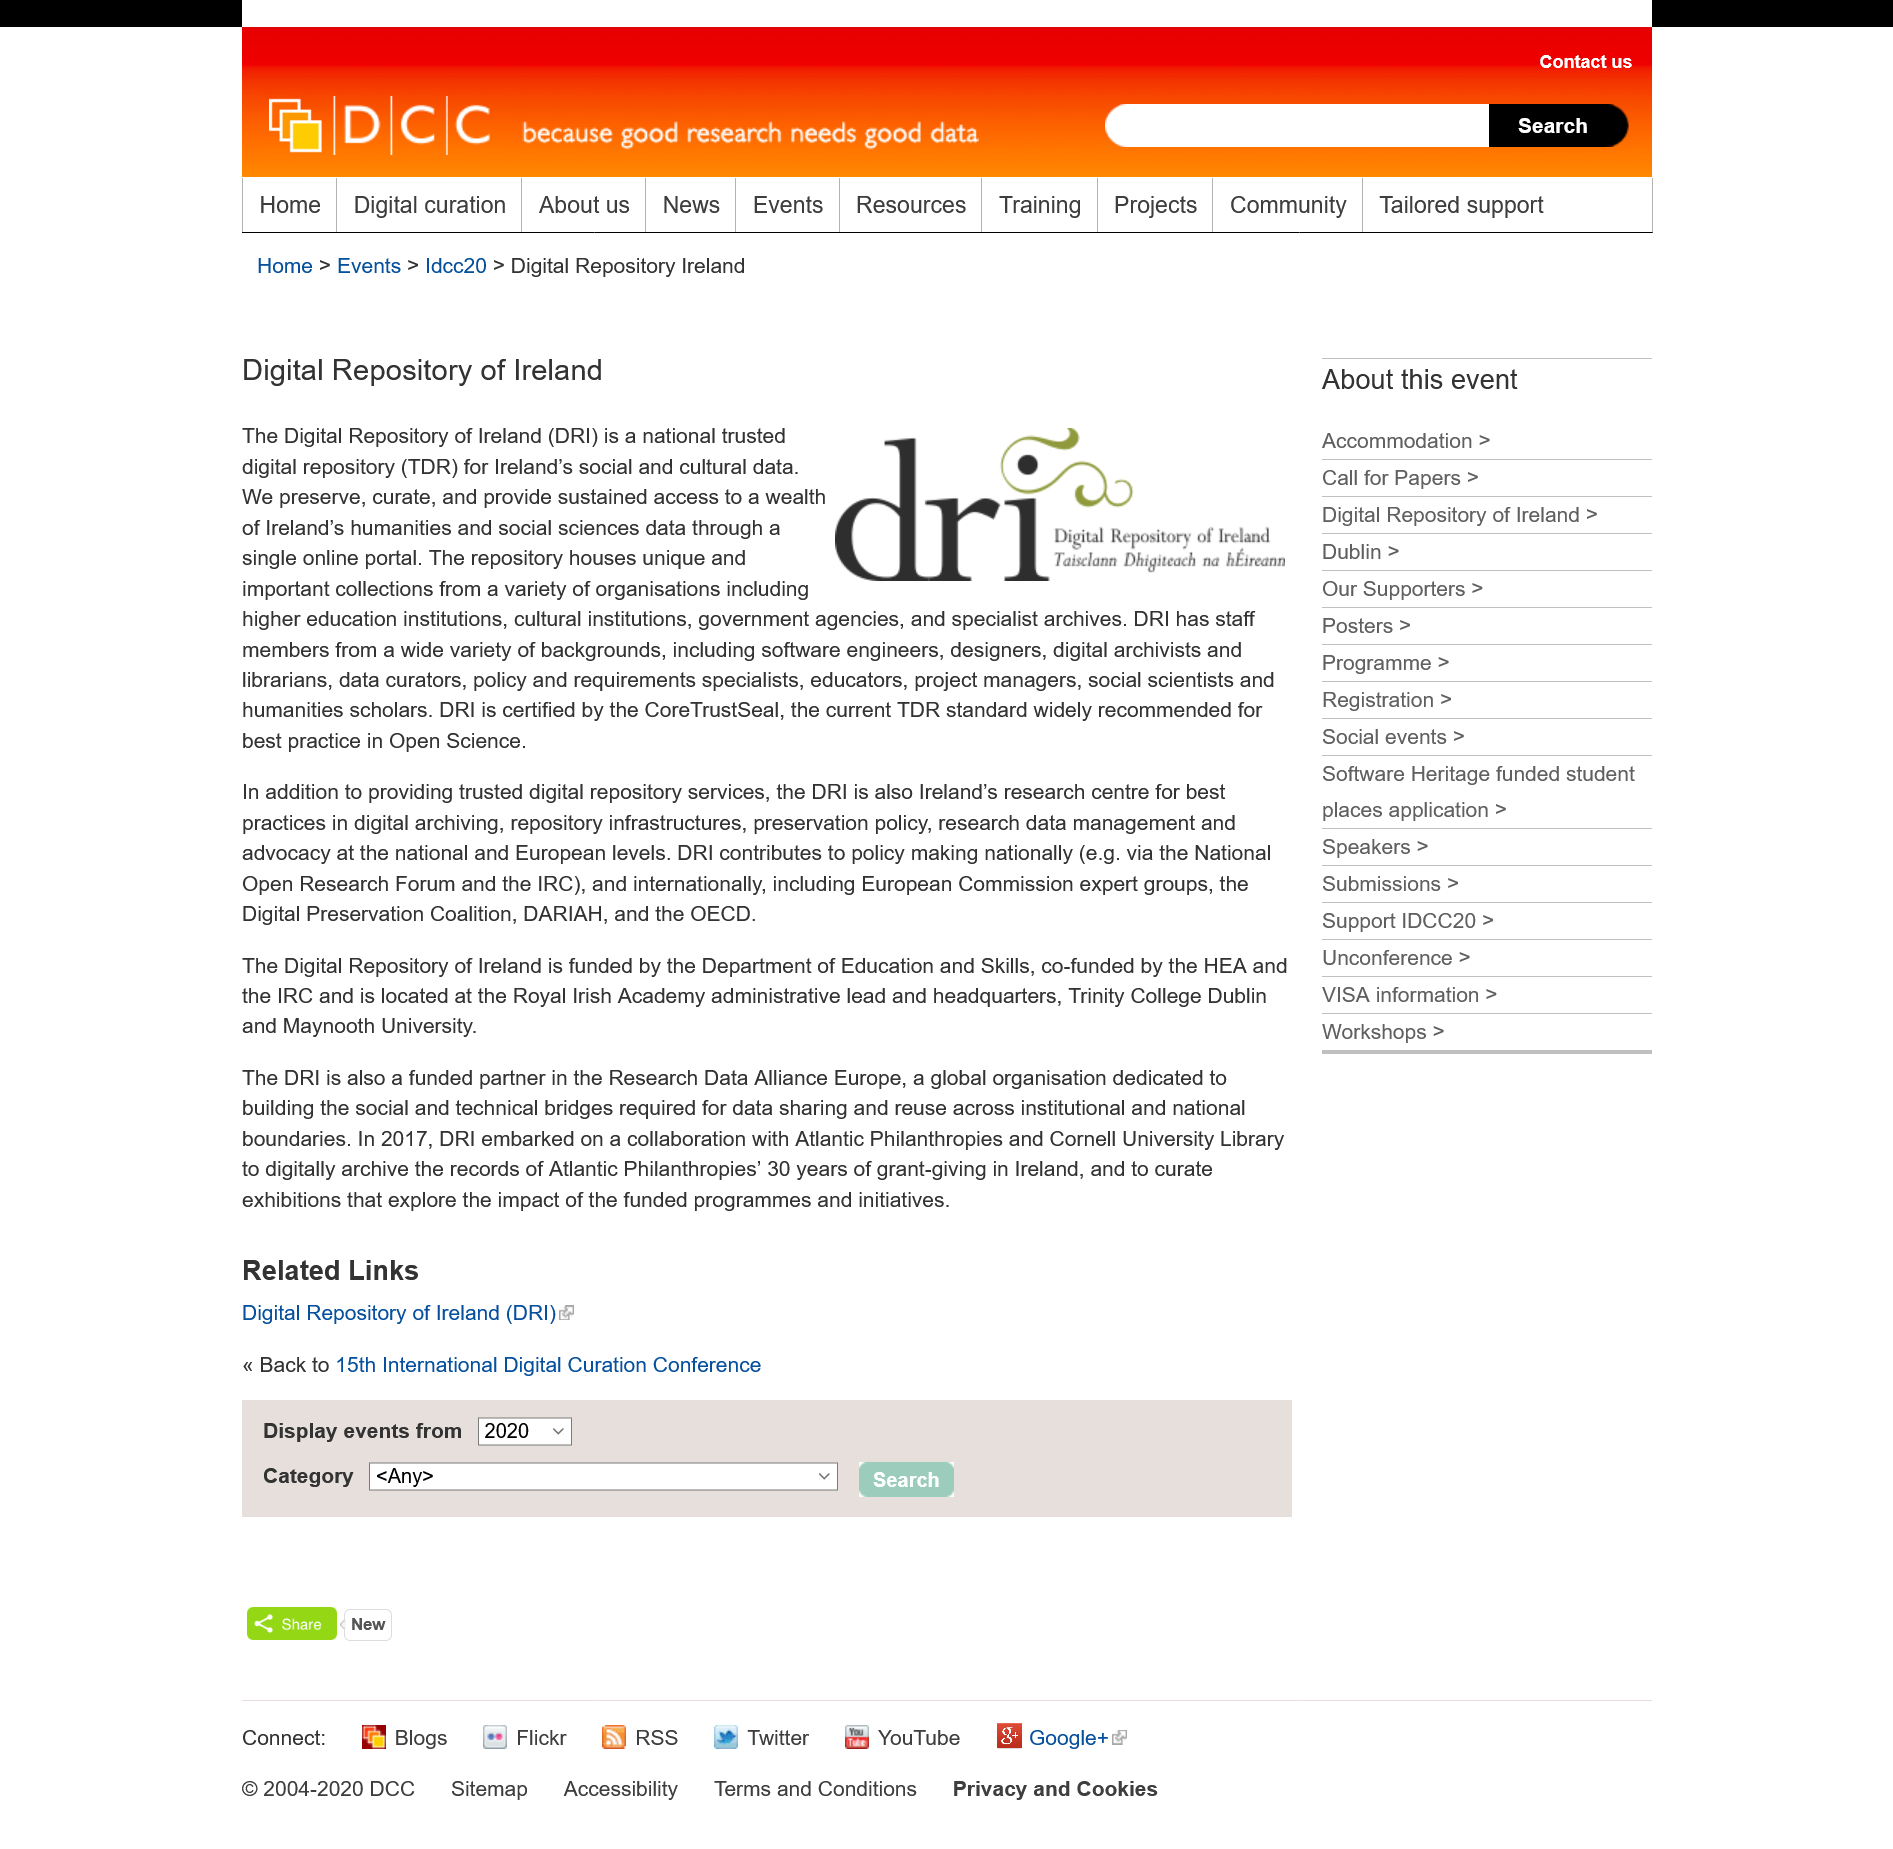Give some essential details in this illustration. The acronym DRI stands for Digital Repository of Ireland, which is a digital archive that stores and preserves electronic records and data. Yes, the DRI houses collections from higher education institutions. The Digital Repository Infrastructure (DRI) has been certified by CoreTrustSeal. 